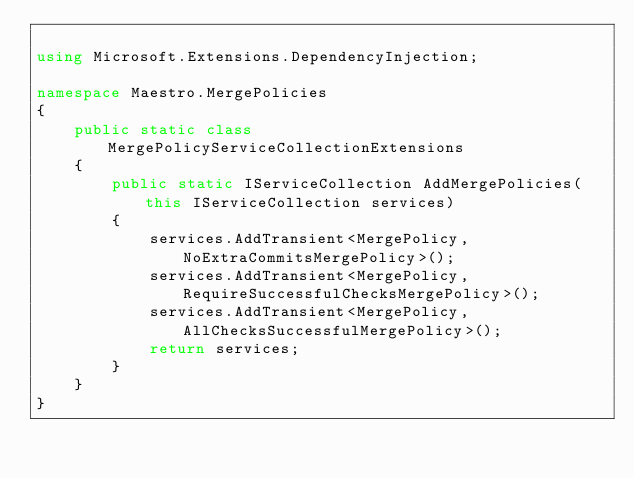Convert code to text. <code><loc_0><loc_0><loc_500><loc_500><_C#_>
using Microsoft.Extensions.DependencyInjection;

namespace Maestro.MergePolicies
{
    public static class MergePolicyServiceCollectionExtensions
    {
        public static IServiceCollection AddMergePolicies(this IServiceCollection services)
        {
            services.AddTransient<MergePolicy, NoExtraCommitsMergePolicy>();
            services.AddTransient<MergePolicy, RequireSuccessfulChecksMergePolicy>();
            services.AddTransient<MergePolicy, AllChecksSuccessfulMergePolicy>();
            return services;
        }
    }
}
</code> 